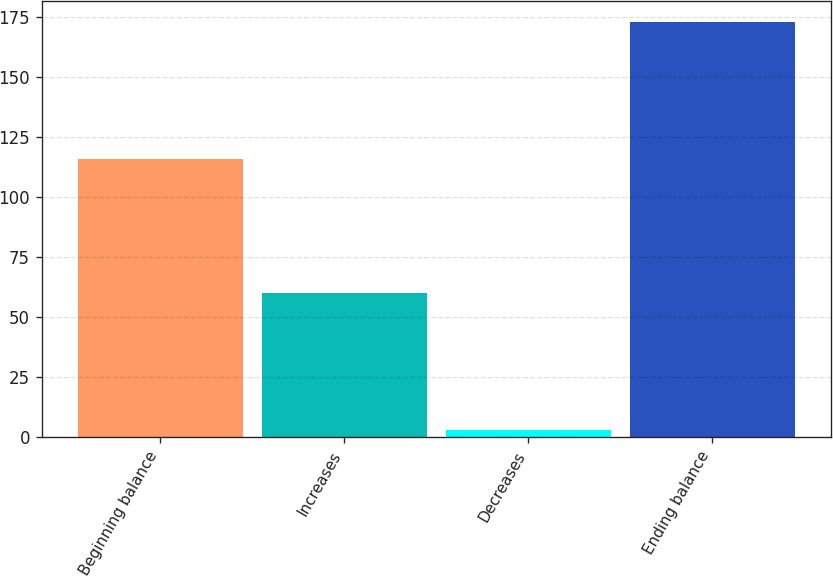Convert chart to OTSL. <chart><loc_0><loc_0><loc_500><loc_500><bar_chart><fcel>Beginning balance<fcel>Increases<fcel>Decreases<fcel>Ending balance<nl><fcel>116<fcel>60<fcel>3<fcel>173<nl></chart> 